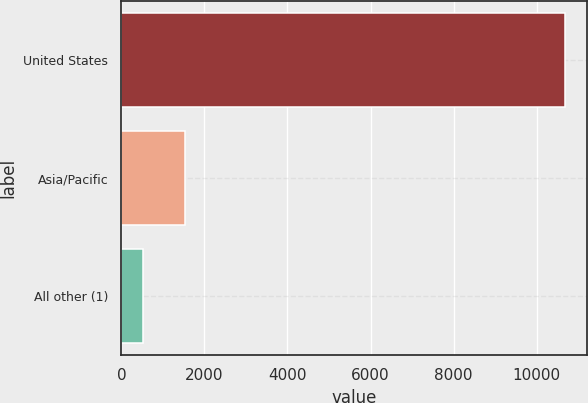Convert chart. <chart><loc_0><loc_0><loc_500><loc_500><bar_chart><fcel>United States<fcel>Asia/Pacific<fcel>All other (1)<nl><fcel>10676<fcel>1527.5<fcel>511<nl></chart> 